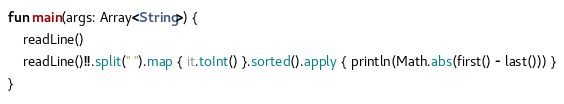<code> <loc_0><loc_0><loc_500><loc_500><_Kotlin_>fun main(args: Array<String>) {
    readLine()
    readLine()!!.split(" ").map { it.toInt() }.sorted().apply { println(Math.abs(first() - last())) }
}</code> 